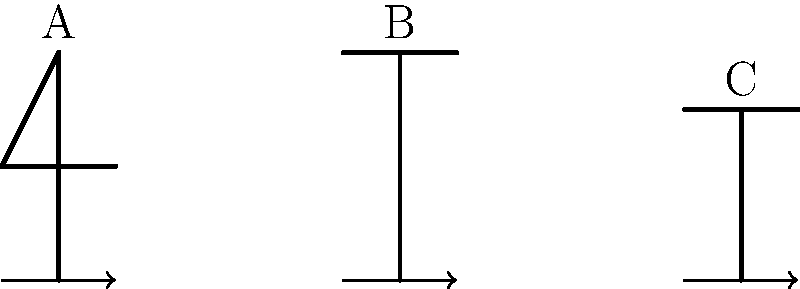In the context of a gymnast's rotation, rank the moment of inertia for the three body positions (A, B, and C) shown in the stick figure illustrations from highest to lowest. How does this ranking relate to the angular velocity of the gymnast's rotation? To answer this question, we need to consider the principles of moment of inertia and its relationship to angular velocity in rotational motion. Let's break it down step by step:

1. Moment of inertia (I) is a measure of an object's resistance to rotational acceleration. It depends on the mass distribution of the body relative to the axis of rotation.

2. The formula for moment of inertia is $I = \sum mr^2$, where m is the mass of each particle and r is its distance from the axis of rotation.

3. Analyzing the three positions:
   A: Arms and legs extended, forming a "T" shape
   B: Arms extended above the head, legs straight
   C: Body in a tucked position, arms and legs close to the body

4. Ranking the moments of inertia:
   A > B > C

   Explanation:
   - Position A has the greatest distribution of mass away from the rotation axis, resulting in the highest moment of inertia.
   - Position B has the arms extended but closer to the axis than in A, resulting in a lower moment of inertia than A.
   - Position C has the mass concentrated close to the rotation axis, resulting in the lowest moment of inertia.

5. Relationship to angular velocity:
   The conservation of angular momentum states that $L = I\omega$ is constant during the rotation, where L is angular momentum, I is moment of inertia, and ω is angular velocity.

6. As $L = I\omega$ is constant, we can deduce that $I$ and $\omega$ are inversely proportional. This means that when I decreases, ω must increase to maintain the same angular momentum.

7. Therefore, the ranking of angular velocities will be inverse to the ranking of moments of inertia:
   C > B > A

   The tucked position (C) will have the highest angular velocity, while the extended "T" position (A) will have the lowest.
Answer: Moment of inertia ranking: A > B > C; Angular velocity ranking: C > B > A 